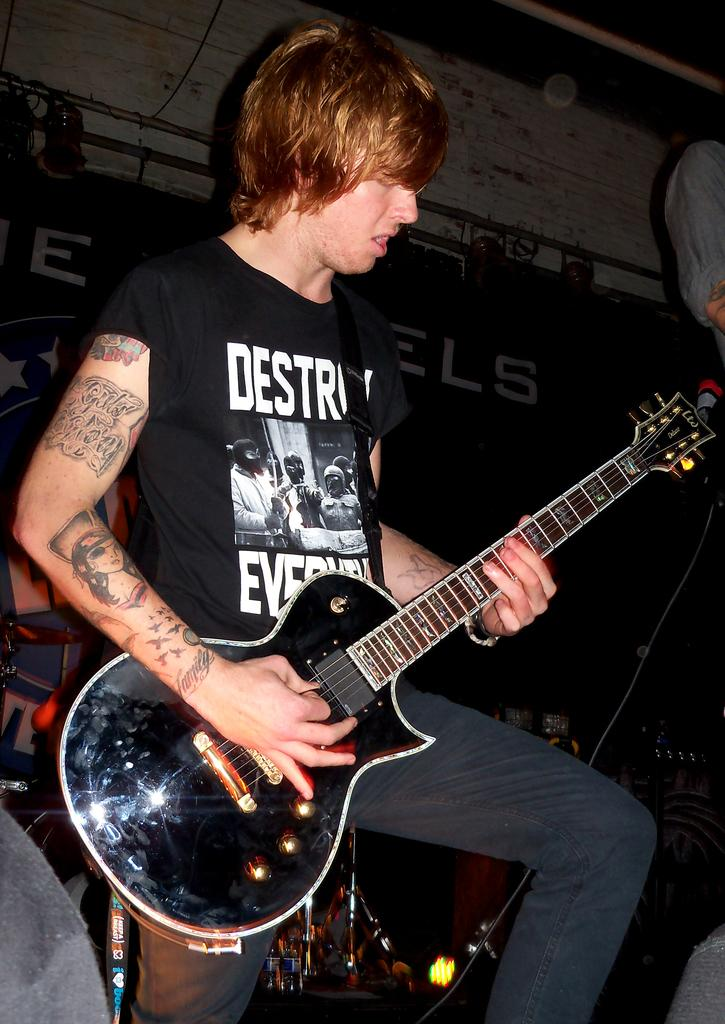What is the main subject of the image? There is a person in the image. What is the person wearing? The person is wearing a black dress. What is the person holding in the image? The person is holding a guitar. What can be seen in the background of the image? There are poles and lights in the background of the image. How many men can be seen in the image? There is no mention of men in the image; it features a person who is not identified as male or female. What type of detail can be seen on the person's eye in the image? There is no detail visible on the person's eye in the image. 